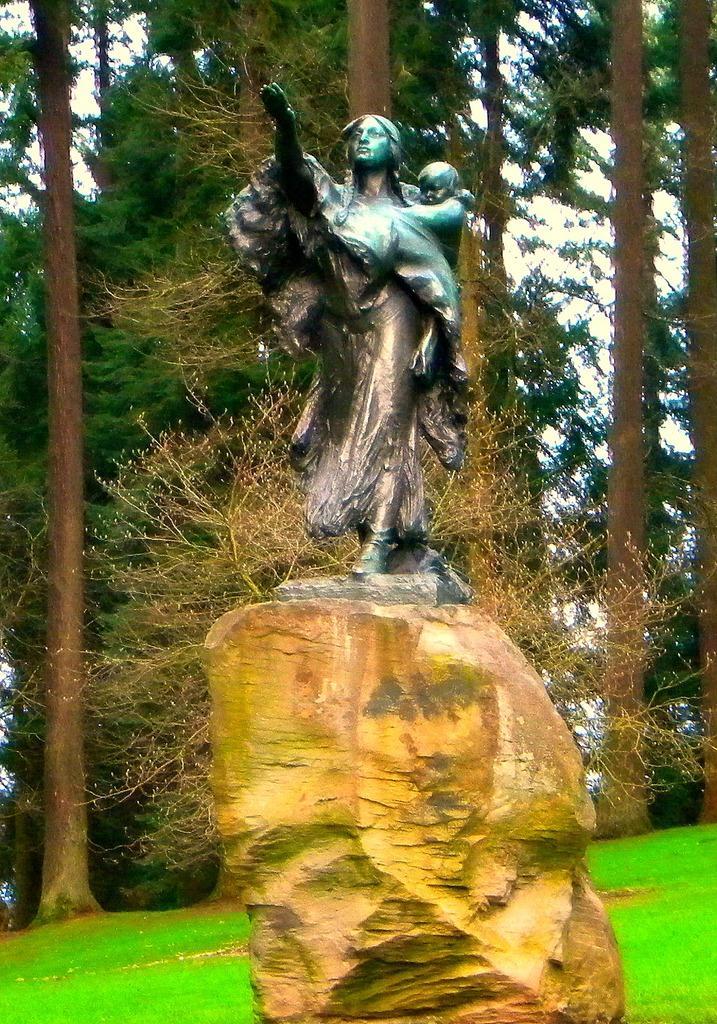Please provide a concise description of this image. In this image there is a statue of a person on the rock. Person is carrying a baby. Behind the statue there are few trees on the grass land. 